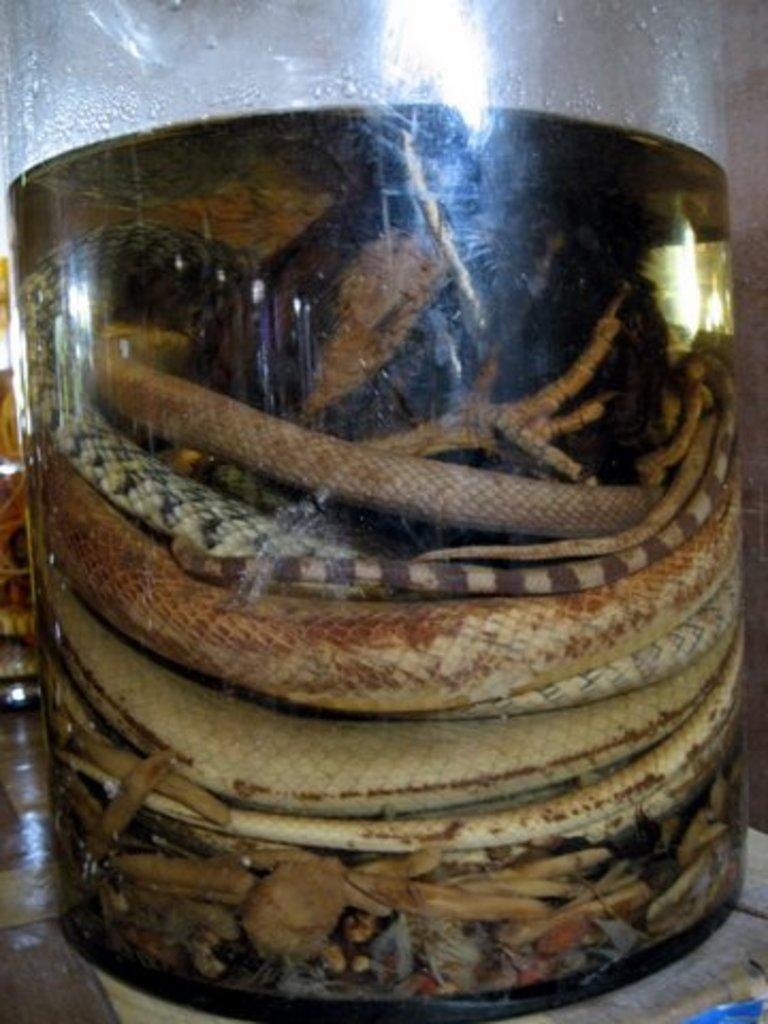What type of container is present in the image? There is a glass tank in the image. What is inside the glass tank? There is water in the glass tank. What else can be seen in the glass tank? There are animals in the glass tank. Can you describe the colors of the animals in the glass tank? The animals have cream, brown, and black colors. What type of ink is used to color the animals in the image? There is no ink present in the image; the animals' colors are natural. 